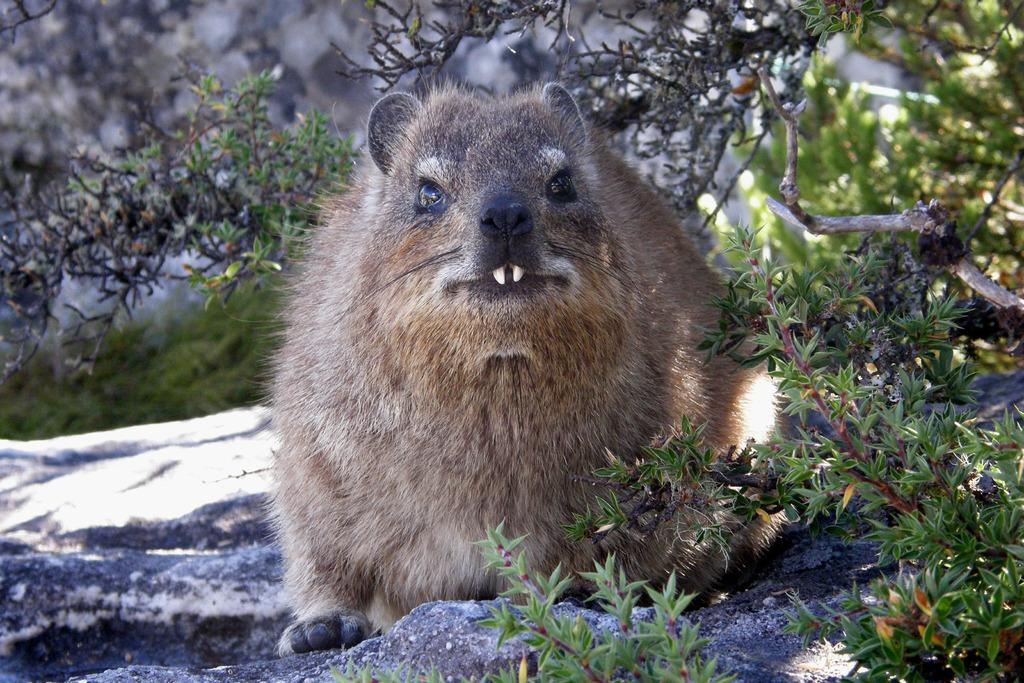What type of animal is in the image? The type of animal cannot be determined from the provided facts. Where is the animal located in the image? The animal is on a rock in the image. What can be seen in the background of the image? There are trees with branches and leaves in the image. How would you describe the clarity of the background in the image? The background of the image appears blurry. What color is the room in the image? There is no room present in the image; it features an animal on a rock with trees in the background. How many times does the animal jump in the image? The provided facts do not mention any jumping or movement by the animal, so it cannot be determined from the image. 